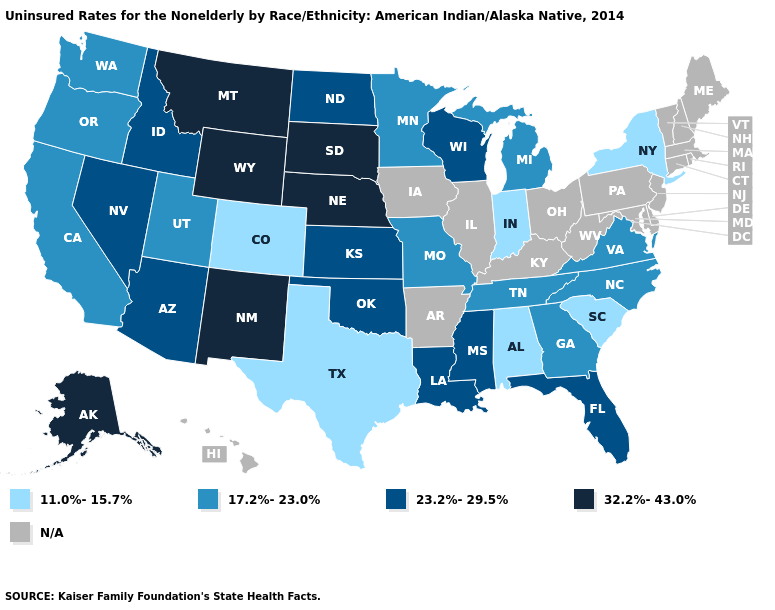Which states have the lowest value in the USA?
Be succinct. Alabama, Colorado, Indiana, New York, South Carolina, Texas. Does Texas have the lowest value in the USA?
Write a very short answer. Yes. What is the lowest value in states that border Ohio?
Answer briefly. 11.0%-15.7%. What is the lowest value in the West?
Keep it brief. 11.0%-15.7%. What is the value of Tennessee?
Write a very short answer. 17.2%-23.0%. Name the states that have a value in the range N/A?
Quick response, please. Arkansas, Connecticut, Delaware, Hawaii, Illinois, Iowa, Kentucky, Maine, Maryland, Massachusetts, New Hampshire, New Jersey, Ohio, Pennsylvania, Rhode Island, Vermont, West Virginia. How many symbols are there in the legend?
Short answer required. 5. Which states have the highest value in the USA?
Quick response, please. Alaska, Montana, Nebraska, New Mexico, South Dakota, Wyoming. What is the lowest value in the Northeast?
Be succinct. 11.0%-15.7%. Name the states that have a value in the range 17.2%-23.0%?
Answer briefly. California, Georgia, Michigan, Minnesota, Missouri, North Carolina, Oregon, Tennessee, Utah, Virginia, Washington. Name the states that have a value in the range N/A?
Answer briefly. Arkansas, Connecticut, Delaware, Hawaii, Illinois, Iowa, Kentucky, Maine, Maryland, Massachusetts, New Hampshire, New Jersey, Ohio, Pennsylvania, Rhode Island, Vermont, West Virginia. 